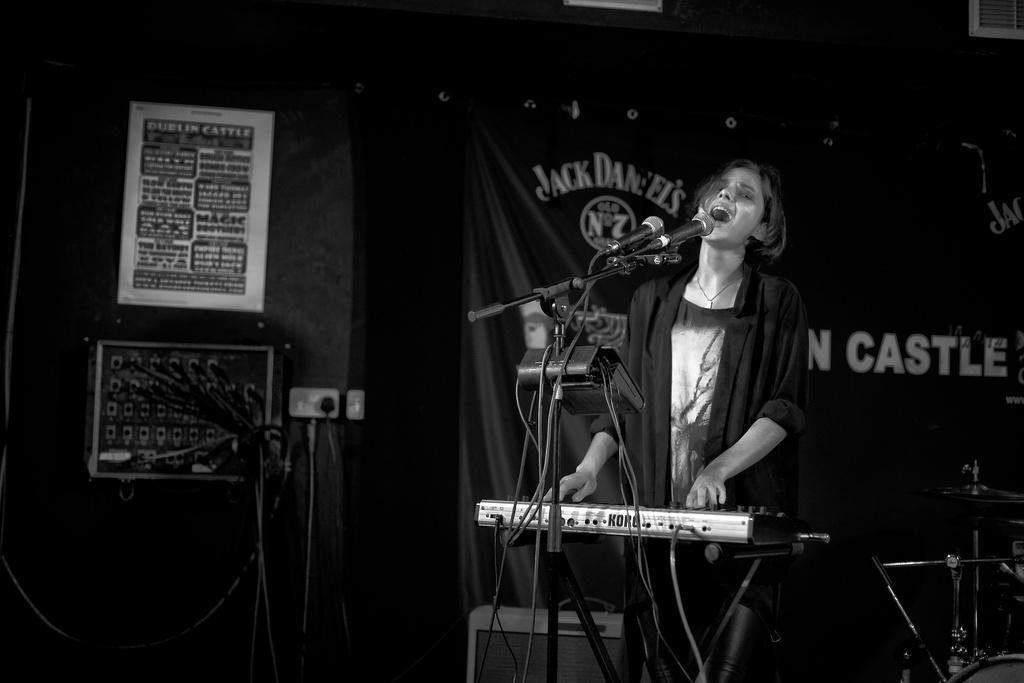How would you summarize this image in a sentence or two? It is the black and white image in which there is a girl singing in front of the mic while playing the keyboard. In the background there is a banner. On the left side there is a switch board. On the right side there are drums and musical plates. 